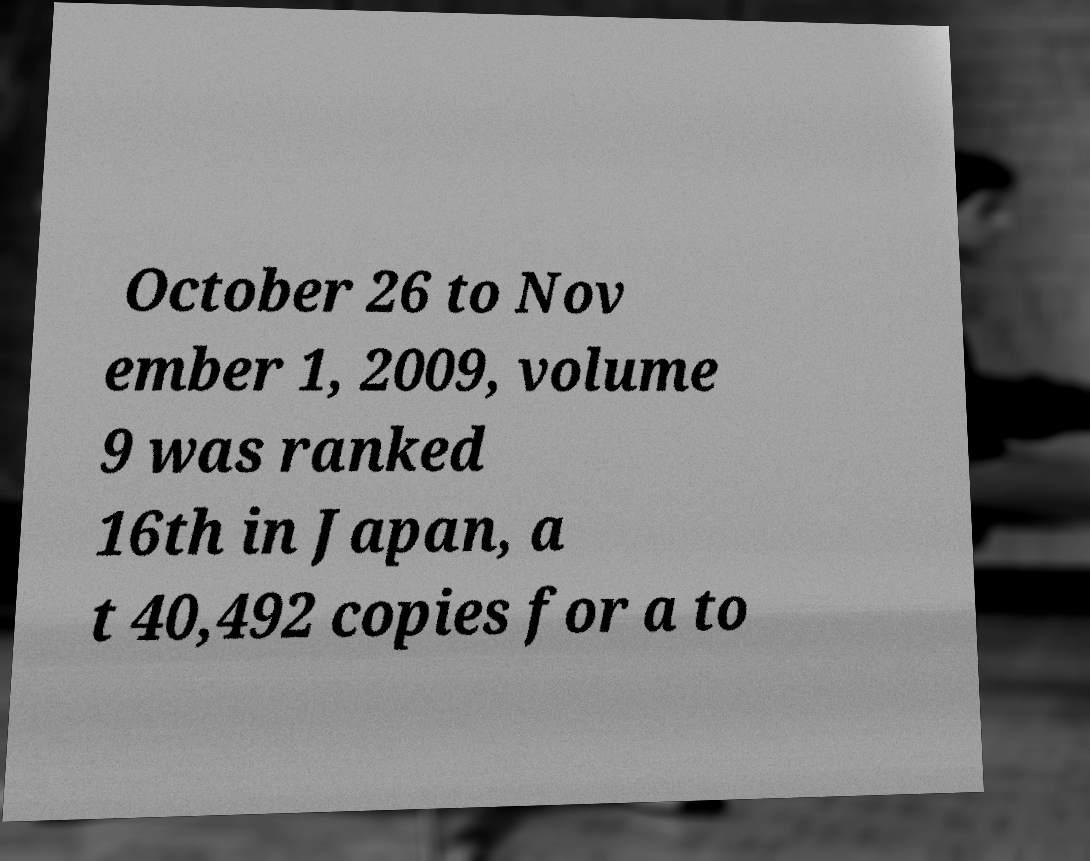There's text embedded in this image that I need extracted. Can you transcribe it verbatim? October 26 to Nov ember 1, 2009, volume 9 was ranked 16th in Japan, a t 40,492 copies for a to 